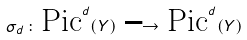Convert formula to latex. <formula><loc_0><loc_0><loc_500><loc_500>\sigma _ { d } \, \colon \, \text {Pic} ^ { d } ( Y ) \, \longrightarrow \, \text {Pic} ^ { d } ( Y )</formula> 